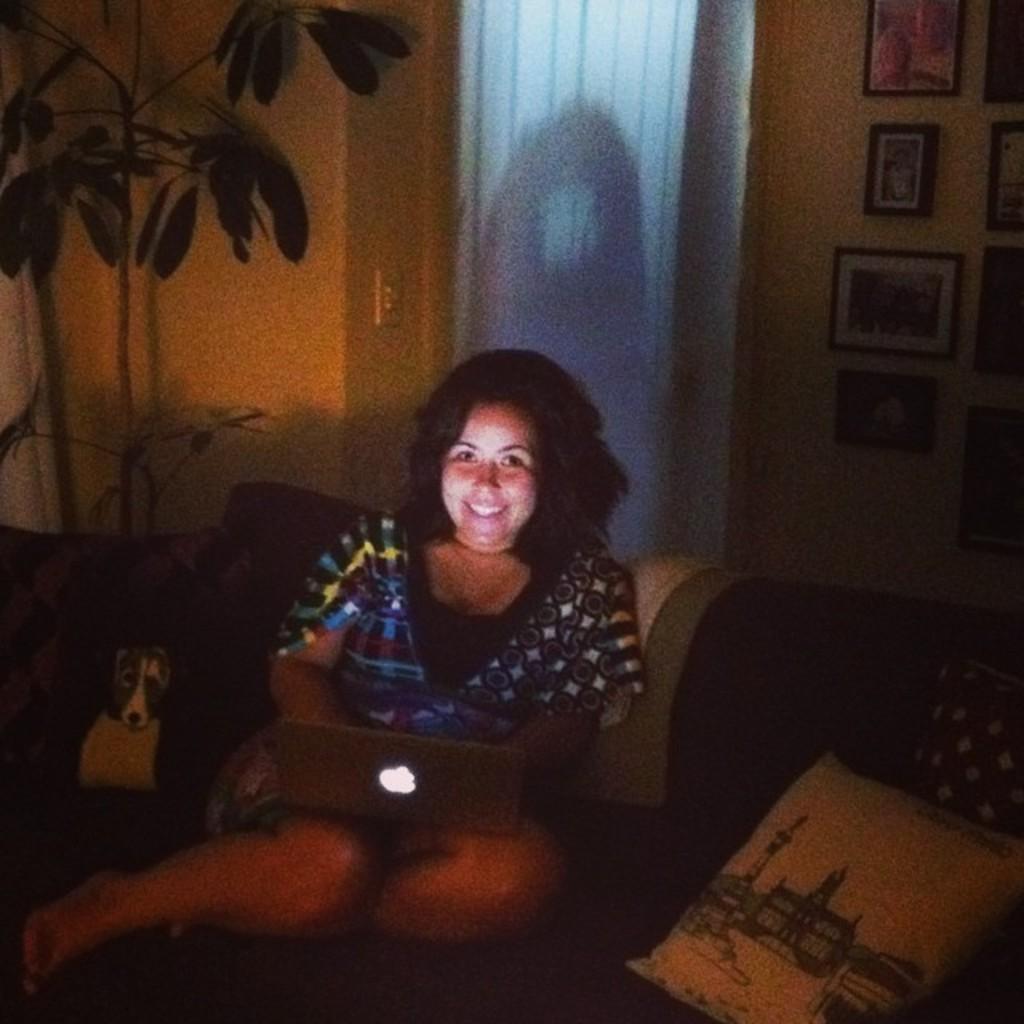In one or two sentences, can you explain what this image depicts? Here in this picture we can see a woman sitting on a couch with laptop on her and we can see she is smiling and beside her we can see a cushion and a dog present over there and behind her on the wall we can see portraits and we can see a plant on the left side present over there. 